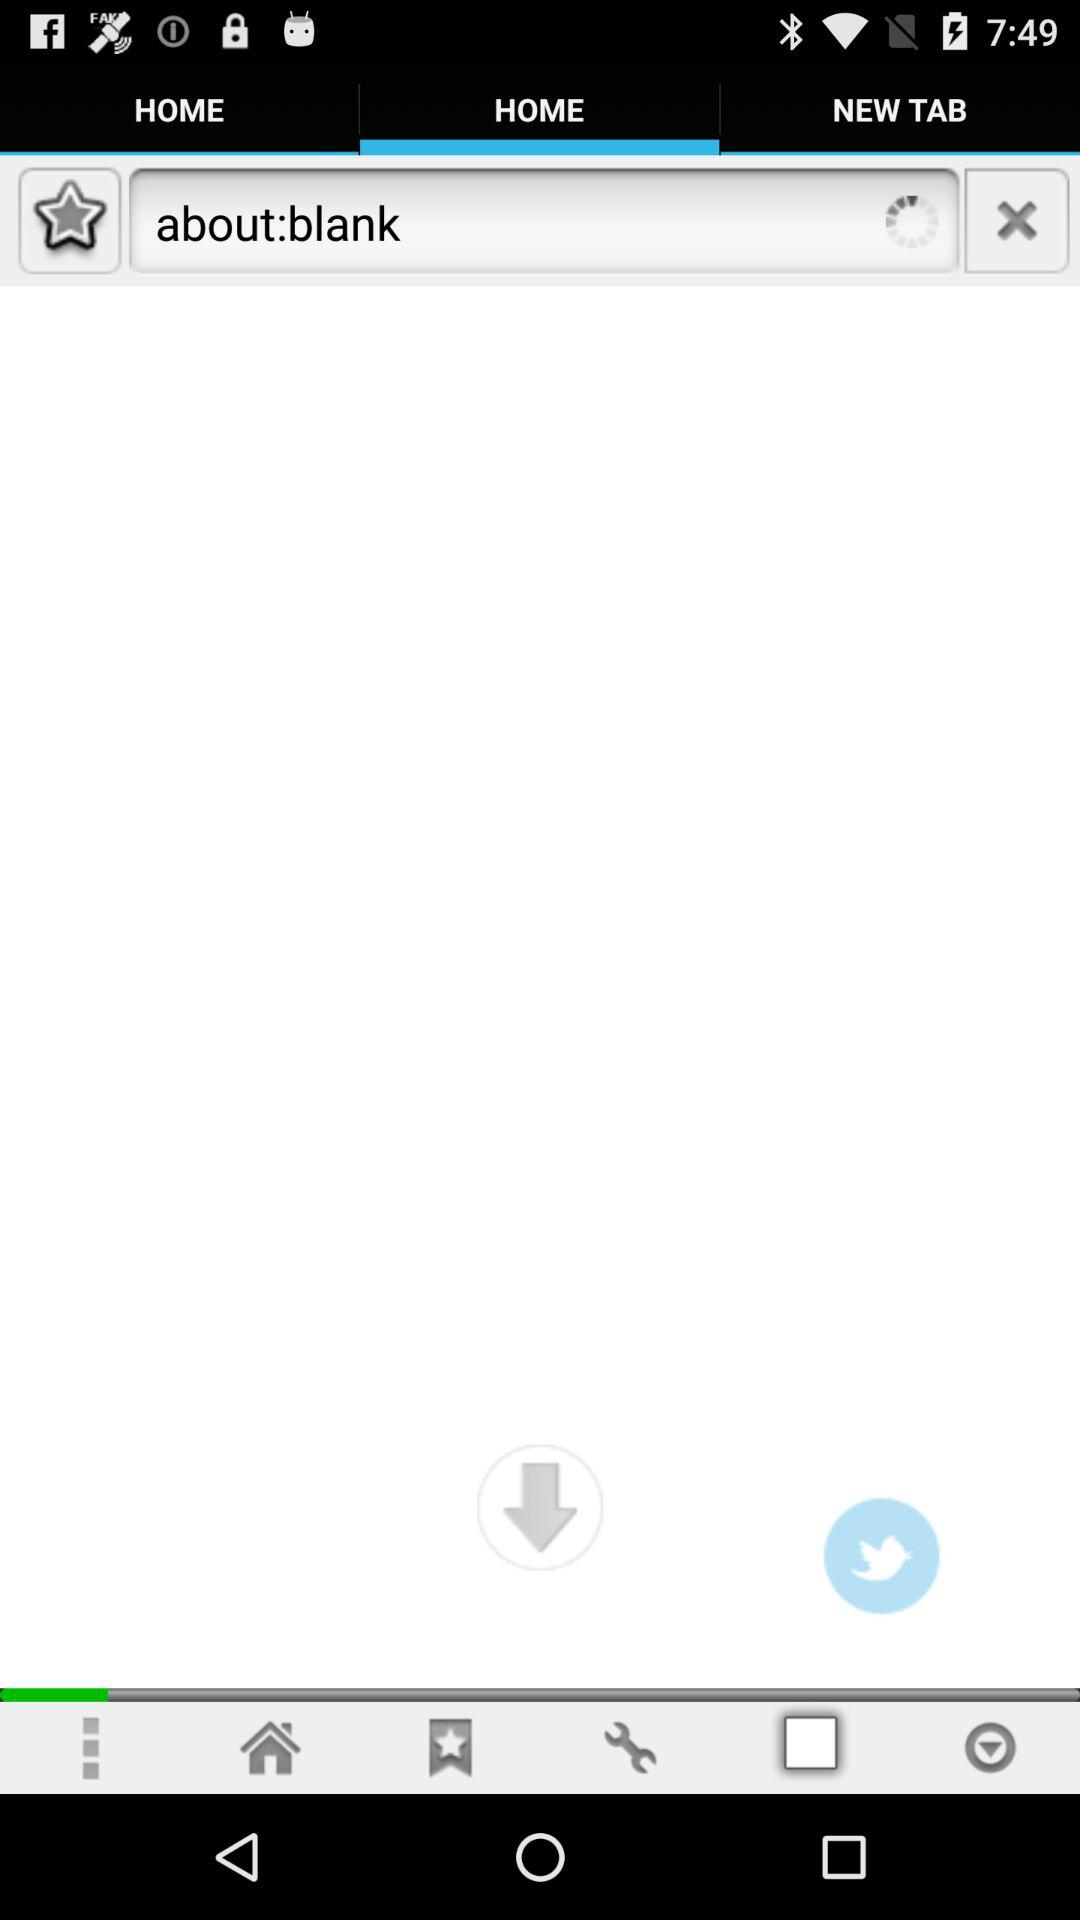What is written in the search field? In the search field, "about:blank" is written. 